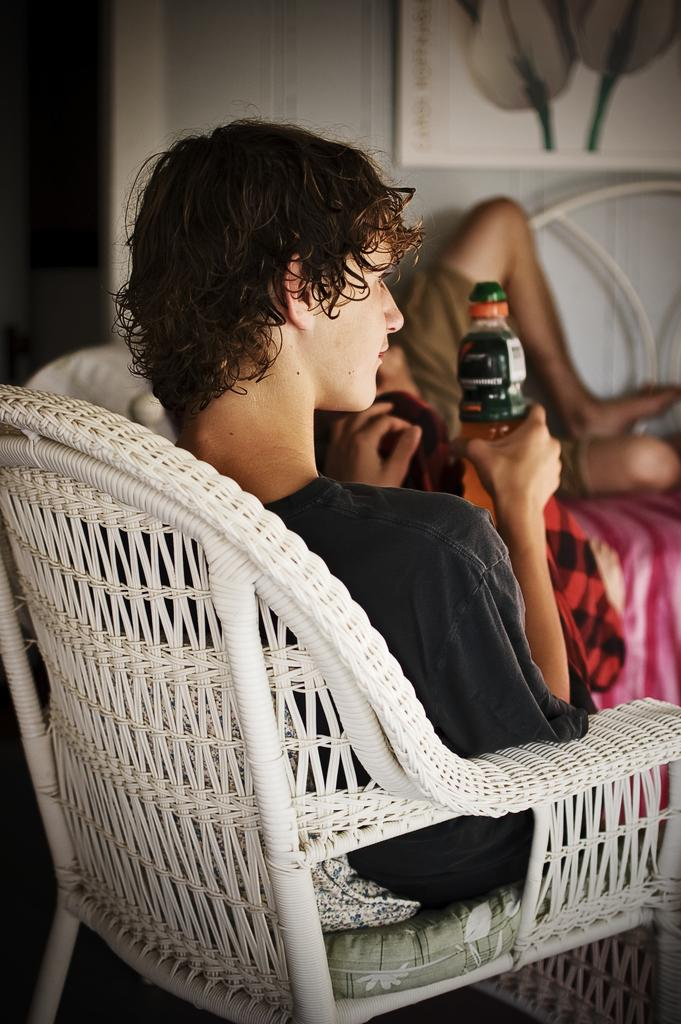What is the man in the image doing? The man is sitting on a chair in the image. What is the man holding in his hand? The man is holding a bottle in his hand. Can you describe anything on the wall in the image? There is a phone frame of flowers on the wall in the image. What type of shoe is the man wearing in the image? There is no shoe visible in the image, as the man is sitting on a chair and his feet are not shown. 